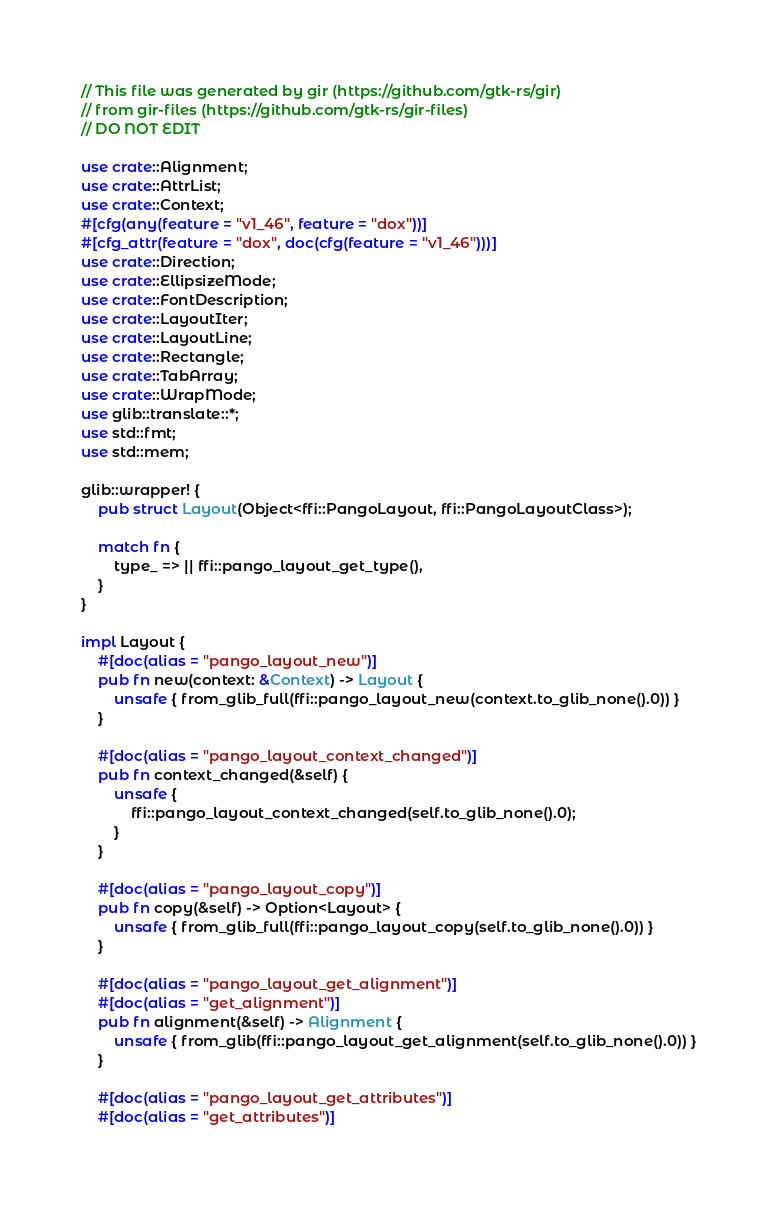Convert code to text. <code><loc_0><loc_0><loc_500><loc_500><_Rust_>// This file was generated by gir (https://github.com/gtk-rs/gir)
// from gir-files (https://github.com/gtk-rs/gir-files)
// DO NOT EDIT

use crate::Alignment;
use crate::AttrList;
use crate::Context;
#[cfg(any(feature = "v1_46", feature = "dox"))]
#[cfg_attr(feature = "dox", doc(cfg(feature = "v1_46")))]
use crate::Direction;
use crate::EllipsizeMode;
use crate::FontDescription;
use crate::LayoutIter;
use crate::LayoutLine;
use crate::Rectangle;
use crate::TabArray;
use crate::WrapMode;
use glib::translate::*;
use std::fmt;
use std::mem;

glib::wrapper! {
    pub struct Layout(Object<ffi::PangoLayout, ffi::PangoLayoutClass>);

    match fn {
        type_ => || ffi::pango_layout_get_type(),
    }
}

impl Layout {
    #[doc(alias = "pango_layout_new")]
    pub fn new(context: &Context) -> Layout {
        unsafe { from_glib_full(ffi::pango_layout_new(context.to_glib_none().0)) }
    }

    #[doc(alias = "pango_layout_context_changed")]
    pub fn context_changed(&self) {
        unsafe {
            ffi::pango_layout_context_changed(self.to_glib_none().0);
        }
    }

    #[doc(alias = "pango_layout_copy")]
    pub fn copy(&self) -> Option<Layout> {
        unsafe { from_glib_full(ffi::pango_layout_copy(self.to_glib_none().0)) }
    }

    #[doc(alias = "pango_layout_get_alignment")]
    #[doc(alias = "get_alignment")]
    pub fn alignment(&self) -> Alignment {
        unsafe { from_glib(ffi::pango_layout_get_alignment(self.to_glib_none().0)) }
    }

    #[doc(alias = "pango_layout_get_attributes")]
    #[doc(alias = "get_attributes")]</code> 